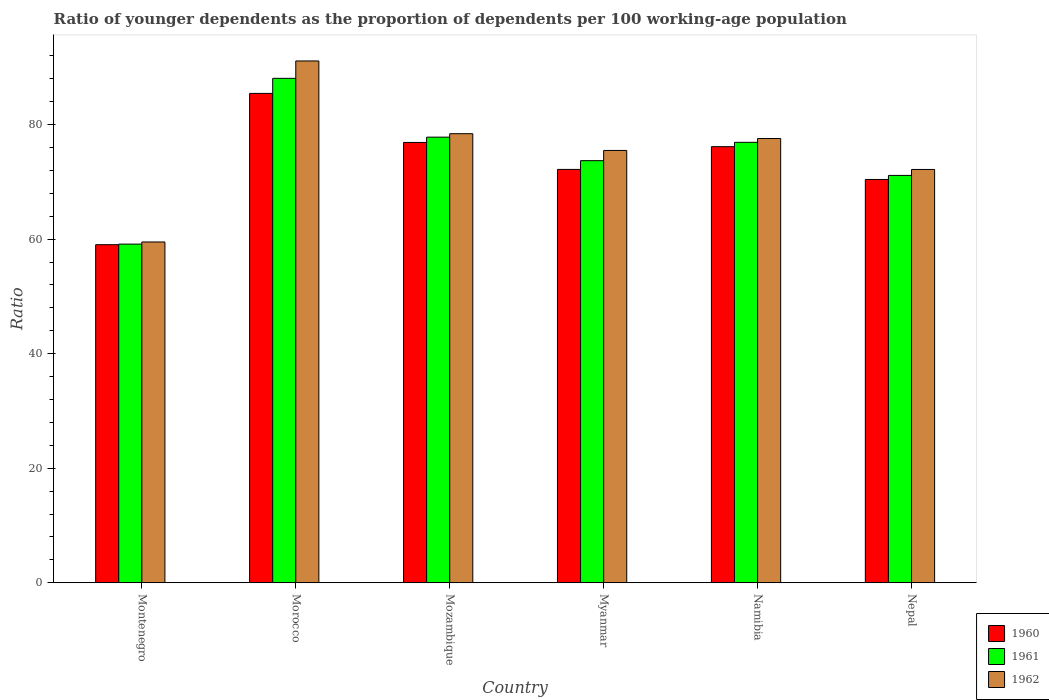How many different coloured bars are there?
Provide a short and direct response. 3. How many bars are there on the 1st tick from the right?
Provide a succinct answer. 3. What is the label of the 4th group of bars from the left?
Offer a terse response. Myanmar. What is the age dependency ratio(young) in 1962 in Morocco?
Make the answer very short. 91.12. Across all countries, what is the maximum age dependency ratio(young) in 1960?
Offer a very short reply. 85.46. Across all countries, what is the minimum age dependency ratio(young) in 1960?
Provide a succinct answer. 59.03. In which country was the age dependency ratio(young) in 1962 maximum?
Offer a very short reply. Morocco. In which country was the age dependency ratio(young) in 1961 minimum?
Your answer should be compact. Montenegro. What is the total age dependency ratio(young) in 1961 in the graph?
Your answer should be very brief. 446.8. What is the difference between the age dependency ratio(young) in 1962 in Mozambique and that in Namibia?
Your answer should be very brief. 0.84. What is the difference between the age dependency ratio(young) in 1961 in Montenegro and the age dependency ratio(young) in 1962 in Namibia?
Your answer should be compact. -18.44. What is the average age dependency ratio(young) in 1962 per country?
Offer a very short reply. 75.72. What is the difference between the age dependency ratio(young) of/in 1961 and age dependency ratio(young) of/in 1960 in Morocco?
Ensure brevity in your answer.  2.63. What is the ratio of the age dependency ratio(young) in 1961 in Montenegro to that in Mozambique?
Keep it short and to the point. 0.76. Is the age dependency ratio(young) in 1960 in Montenegro less than that in Myanmar?
Give a very brief answer. Yes. What is the difference between the highest and the second highest age dependency ratio(young) in 1960?
Give a very brief answer. -8.57. What is the difference between the highest and the lowest age dependency ratio(young) in 1962?
Provide a short and direct response. 31.61. Is the sum of the age dependency ratio(young) in 1962 in Montenegro and Namibia greater than the maximum age dependency ratio(young) in 1961 across all countries?
Make the answer very short. Yes. What does the 1st bar from the left in Mozambique represents?
Give a very brief answer. 1960. What does the 1st bar from the right in Mozambique represents?
Your answer should be compact. 1962. Are all the bars in the graph horizontal?
Your answer should be very brief. No. How many countries are there in the graph?
Give a very brief answer. 6. What is the difference between two consecutive major ticks on the Y-axis?
Offer a terse response. 20. Are the values on the major ticks of Y-axis written in scientific E-notation?
Keep it short and to the point. No. Does the graph contain grids?
Offer a very short reply. No. How many legend labels are there?
Offer a very short reply. 3. How are the legend labels stacked?
Provide a succinct answer. Vertical. What is the title of the graph?
Provide a succinct answer. Ratio of younger dependents as the proportion of dependents per 100 working-age population. Does "1996" appear as one of the legend labels in the graph?
Provide a succinct answer. No. What is the label or title of the Y-axis?
Offer a terse response. Ratio. What is the Ratio of 1960 in Montenegro?
Keep it short and to the point. 59.03. What is the Ratio in 1961 in Montenegro?
Offer a very short reply. 59.14. What is the Ratio of 1962 in Montenegro?
Your answer should be very brief. 59.51. What is the Ratio of 1960 in Morocco?
Your answer should be compact. 85.46. What is the Ratio in 1961 in Morocco?
Your response must be concise. 88.09. What is the Ratio in 1962 in Morocco?
Give a very brief answer. 91.12. What is the Ratio of 1960 in Mozambique?
Ensure brevity in your answer.  76.89. What is the Ratio in 1961 in Mozambique?
Your response must be concise. 77.82. What is the Ratio of 1962 in Mozambique?
Give a very brief answer. 78.42. What is the Ratio of 1960 in Myanmar?
Ensure brevity in your answer.  72.18. What is the Ratio of 1961 in Myanmar?
Offer a terse response. 73.71. What is the Ratio of 1962 in Myanmar?
Ensure brevity in your answer.  75.49. What is the Ratio of 1960 in Namibia?
Your response must be concise. 76.15. What is the Ratio of 1961 in Namibia?
Give a very brief answer. 76.91. What is the Ratio of 1962 in Namibia?
Offer a terse response. 77.58. What is the Ratio of 1960 in Nepal?
Offer a terse response. 70.43. What is the Ratio in 1961 in Nepal?
Your response must be concise. 71.13. What is the Ratio of 1962 in Nepal?
Ensure brevity in your answer.  72.17. Across all countries, what is the maximum Ratio in 1960?
Your answer should be very brief. 85.46. Across all countries, what is the maximum Ratio of 1961?
Give a very brief answer. 88.09. Across all countries, what is the maximum Ratio in 1962?
Provide a succinct answer. 91.12. Across all countries, what is the minimum Ratio of 1960?
Offer a terse response. 59.03. Across all countries, what is the minimum Ratio of 1961?
Give a very brief answer. 59.14. Across all countries, what is the minimum Ratio of 1962?
Provide a succinct answer. 59.51. What is the total Ratio in 1960 in the graph?
Your answer should be compact. 440.14. What is the total Ratio in 1961 in the graph?
Your response must be concise. 446.8. What is the total Ratio in 1962 in the graph?
Your response must be concise. 454.3. What is the difference between the Ratio of 1960 in Montenegro and that in Morocco?
Offer a terse response. -26.42. What is the difference between the Ratio in 1961 in Montenegro and that in Morocco?
Offer a terse response. -28.95. What is the difference between the Ratio of 1962 in Montenegro and that in Morocco?
Your answer should be very brief. -31.61. What is the difference between the Ratio of 1960 in Montenegro and that in Mozambique?
Offer a very short reply. -17.86. What is the difference between the Ratio of 1961 in Montenegro and that in Mozambique?
Offer a very short reply. -18.68. What is the difference between the Ratio of 1962 in Montenegro and that in Mozambique?
Keep it short and to the point. -18.91. What is the difference between the Ratio of 1960 in Montenegro and that in Myanmar?
Give a very brief answer. -13.15. What is the difference between the Ratio of 1961 in Montenegro and that in Myanmar?
Keep it short and to the point. -14.57. What is the difference between the Ratio of 1962 in Montenegro and that in Myanmar?
Your response must be concise. -15.98. What is the difference between the Ratio in 1960 in Montenegro and that in Namibia?
Make the answer very short. -17.12. What is the difference between the Ratio in 1961 in Montenegro and that in Namibia?
Your response must be concise. -17.78. What is the difference between the Ratio in 1962 in Montenegro and that in Namibia?
Your answer should be compact. -18.07. What is the difference between the Ratio in 1960 in Montenegro and that in Nepal?
Keep it short and to the point. -11.39. What is the difference between the Ratio in 1961 in Montenegro and that in Nepal?
Keep it short and to the point. -11.99. What is the difference between the Ratio in 1962 in Montenegro and that in Nepal?
Offer a terse response. -12.66. What is the difference between the Ratio of 1960 in Morocco and that in Mozambique?
Give a very brief answer. 8.57. What is the difference between the Ratio of 1961 in Morocco and that in Mozambique?
Your answer should be compact. 10.27. What is the difference between the Ratio of 1962 in Morocco and that in Mozambique?
Ensure brevity in your answer.  12.7. What is the difference between the Ratio of 1960 in Morocco and that in Myanmar?
Provide a succinct answer. 13.28. What is the difference between the Ratio in 1961 in Morocco and that in Myanmar?
Your answer should be compact. 14.38. What is the difference between the Ratio in 1962 in Morocco and that in Myanmar?
Your response must be concise. 15.63. What is the difference between the Ratio of 1960 in Morocco and that in Namibia?
Your response must be concise. 9.3. What is the difference between the Ratio in 1961 in Morocco and that in Namibia?
Your answer should be compact. 11.17. What is the difference between the Ratio in 1962 in Morocco and that in Namibia?
Give a very brief answer. 13.54. What is the difference between the Ratio of 1960 in Morocco and that in Nepal?
Provide a short and direct response. 15.03. What is the difference between the Ratio of 1961 in Morocco and that in Nepal?
Your answer should be very brief. 16.95. What is the difference between the Ratio of 1962 in Morocco and that in Nepal?
Your answer should be very brief. 18.95. What is the difference between the Ratio in 1960 in Mozambique and that in Myanmar?
Your answer should be compact. 4.71. What is the difference between the Ratio in 1961 in Mozambique and that in Myanmar?
Keep it short and to the point. 4.11. What is the difference between the Ratio in 1962 in Mozambique and that in Myanmar?
Your answer should be very brief. 2.92. What is the difference between the Ratio of 1960 in Mozambique and that in Namibia?
Your response must be concise. 0.74. What is the difference between the Ratio of 1961 in Mozambique and that in Namibia?
Your answer should be very brief. 0.9. What is the difference between the Ratio in 1962 in Mozambique and that in Namibia?
Your answer should be compact. 0.84. What is the difference between the Ratio in 1960 in Mozambique and that in Nepal?
Ensure brevity in your answer.  6.46. What is the difference between the Ratio of 1961 in Mozambique and that in Nepal?
Your answer should be compact. 6.68. What is the difference between the Ratio of 1962 in Mozambique and that in Nepal?
Make the answer very short. 6.24. What is the difference between the Ratio of 1960 in Myanmar and that in Namibia?
Make the answer very short. -3.97. What is the difference between the Ratio in 1961 in Myanmar and that in Namibia?
Offer a terse response. -3.2. What is the difference between the Ratio of 1962 in Myanmar and that in Namibia?
Offer a very short reply. -2.08. What is the difference between the Ratio in 1960 in Myanmar and that in Nepal?
Your answer should be very brief. 1.76. What is the difference between the Ratio in 1961 in Myanmar and that in Nepal?
Keep it short and to the point. 2.58. What is the difference between the Ratio in 1962 in Myanmar and that in Nepal?
Your answer should be compact. 3.32. What is the difference between the Ratio in 1960 in Namibia and that in Nepal?
Your answer should be compact. 5.73. What is the difference between the Ratio of 1961 in Namibia and that in Nepal?
Make the answer very short. 5.78. What is the difference between the Ratio in 1962 in Namibia and that in Nepal?
Offer a very short reply. 5.4. What is the difference between the Ratio in 1960 in Montenegro and the Ratio in 1961 in Morocco?
Make the answer very short. -29.05. What is the difference between the Ratio of 1960 in Montenegro and the Ratio of 1962 in Morocco?
Your response must be concise. -32.09. What is the difference between the Ratio in 1961 in Montenegro and the Ratio in 1962 in Morocco?
Provide a succinct answer. -31.98. What is the difference between the Ratio of 1960 in Montenegro and the Ratio of 1961 in Mozambique?
Provide a short and direct response. -18.78. What is the difference between the Ratio in 1960 in Montenegro and the Ratio in 1962 in Mozambique?
Your answer should be compact. -19.39. What is the difference between the Ratio in 1961 in Montenegro and the Ratio in 1962 in Mozambique?
Your answer should be very brief. -19.28. What is the difference between the Ratio in 1960 in Montenegro and the Ratio in 1961 in Myanmar?
Ensure brevity in your answer.  -14.68. What is the difference between the Ratio in 1960 in Montenegro and the Ratio in 1962 in Myanmar?
Your answer should be very brief. -16.46. What is the difference between the Ratio in 1961 in Montenegro and the Ratio in 1962 in Myanmar?
Offer a terse response. -16.36. What is the difference between the Ratio in 1960 in Montenegro and the Ratio in 1961 in Namibia?
Ensure brevity in your answer.  -17.88. What is the difference between the Ratio in 1960 in Montenegro and the Ratio in 1962 in Namibia?
Provide a succinct answer. -18.55. What is the difference between the Ratio of 1961 in Montenegro and the Ratio of 1962 in Namibia?
Your response must be concise. -18.44. What is the difference between the Ratio in 1960 in Montenegro and the Ratio in 1961 in Nepal?
Make the answer very short. -12.1. What is the difference between the Ratio of 1960 in Montenegro and the Ratio of 1962 in Nepal?
Offer a very short reply. -13.14. What is the difference between the Ratio in 1961 in Montenegro and the Ratio in 1962 in Nepal?
Give a very brief answer. -13.04. What is the difference between the Ratio in 1960 in Morocco and the Ratio in 1961 in Mozambique?
Your response must be concise. 7.64. What is the difference between the Ratio of 1960 in Morocco and the Ratio of 1962 in Mozambique?
Your response must be concise. 7.04. What is the difference between the Ratio of 1961 in Morocco and the Ratio of 1962 in Mozambique?
Provide a succinct answer. 9.67. What is the difference between the Ratio in 1960 in Morocco and the Ratio in 1961 in Myanmar?
Keep it short and to the point. 11.75. What is the difference between the Ratio in 1960 in Morocco and the Ratio in 1962 in Myanmar?
Provide a short and direct response. 9.96. What is the difference between the Ratio in 1961 in Morocco and the Ratio in 1962 in Myanmar?
Provide a succinct answer. 12.59. What is the difference between the Ratio in 1960 in Morocco and the Ratio in 1961 in Namibia?
Offer a very short reply. 8.54. What is the difference between the Ratio of 1960 in Morocco and the Ratio of 1962 in Namibia?
Your answer should be very brief. 7.88. What is the difference between the Ratio in 1961 in Morocco and the Ratio in 1962 in Namibia?
Offer a terse response. 10.51. What is the difference between the Ratio in 1960 in Morocco and the Ratio in 1961 in Nepal?
Ensure brevity in your answer.  14.33. What is the difference between the Ratio in 1960 in Morocco and the Ratio in 1962 in Nepal?
Give a very brief answer. 13.28. What is the difference between the Ratio of 1961 in Morocco and the Ratio of 1962 in Nepal?
Give a very brief answer. 15.91. What is the difference between the Ratio in 1960 in Mozambique and the Ratio in 1961 in Myanmar?
Ensure brevity in your answer.  3.18. What is the difference between the Ratio in 1960 in Mozambique and the Ratio in 1962 in Myanmar?
Your answer should be very brief. 1.4. What is the difference between the Ratio of 1961 in Mozambique and the Ratio of 1962 in Myanmar?
Give a very brief answer. 2.32. What is the difference between the Ratio in 1960 in Mozambique and the Ratio in 1961 in Namibia?
Offer a terse response. -0.02. What is the difference between the Ratio of 1960 in Mozambique and the Ratio of 1962 in Namibia?
Keep it short and to the point. -0.69. What is the difference between the Ratio of 1961 in Mozambique and the Ratio of 1962 in Namibia?
Give a very brief answer. 0.24. What is the difference between the Ratio in 1960 in Mozambique and the Ratio in 1961 in Nepal?
Provide a succinct answer. 5.76. What is the difference between the Ratio in 1960 in Mozambique and the Ratio in 1962 in Nepal?
Give a very brief answer. 4.72. What is the difference between the Ratio in 1961 in Mozambique and the Ratio in 1962 in Nepal?
Offer a very short reply. 5.64. What is the difference between the Ratio in 1960 in Myanmar and the Ratio in 1961 in Namibia?
Offer a very short reply. -4.73. What is the difference between the Ratio in 1960 in Myanmar and the Ratio in 1962 in Namibia?
Your response must be concise. -5.4. What is the difference between the Ratio of 1961 in Myanmar and the Ratio of 1962 in Namibia?
Provide a succinct answer. -3.87. What is the difference between the Ratio in 1960 in Myanmar and the Ratio in 1961 in Nepal?
Keep it short and to the point. 1.05. What is the difference between the Ratio of 1960 in Myanmar and the Ratio of 1962 in Nepal?
Offer a terse response. 0.01. What is the difference between the Ratio in 1961 in Myanmar and the Ratio in 1962 in Nepal?
Your answer should be very brief. 1.54. What is the difference between the Ratio in 1960 in Namibia and the Ratio in 1961 in Nepal?
Give a very brief answer. 5.02. What is the difference between the Ratio in 1960 in Namibia and the Ratio in 1962 in Nepal?
Your response must be concise. 3.98. What is the difference between the Ratio of 1961 in Namibia and the Ratio of 1962 in Nepal?
Offer a very short reply. 4.74. What is the average Ratio in 1960 per country?
Ensure brevity in your answer.  73.36. What is the average Ratio of 1961 per country?
Keep it short and to the point. 74.47. What is the average Ratio of 1962 per country?
Your answer should be compact. 75.72. What is the difference between the Ratio in 1960 and Ratio in 1961 in Montenegro?
Your answer should be very brief. -0.1. What is the difference between the Ratio in 1960 and Ratio in 1962 in Montenegro?
Give a very brief answer. -0.48. What is the difference between the Ratio in 1961 and Ratio in 1962 in Montenegro?
Your answer should be compact. -0.37. What is the difference between the Ratio in 1960 and Ratio in 1961 in Morocco?
Your answer should be very brief. -2.63. What is the difference between the Ratio of 1960 and Ratio of 1962 in Morocco?
Your answer should be very brief. -5.66. What is the difference between the Ratio in 1961 and Ratio in 1962 in Morocco?
Keep it short and to the point. -3.04. What is the difference between the Ratio in 1960 and Ratio in 1961 in Mozambique?
Provide a succinct answer. -0.93. What is the difference between the Ratio in 1960 and Ratio in 1962 in Mozambique?
Keep it short and to the point. -1.53. What is the difference between the Ratio in 1961 and Ratio in 1962 in Mozambique?
Keep it short and to the point. -0.6. What is the difference between the Ratio in 1960 and Ratio in 1961 in Myanmar?
Offer a very short reply. -1.53. What is the difference between the Ratio of 1960 and Ratio of 1962 in Myanmar?
Your answer should be very brief. -3.31. What is the difference between the Ratio of 1961 and Ratio of 1962 in Myanmar?
Give a very brief answer. -1.78. What is the difference between the Ratio of 1960 and Ratio of 1961 in Namibia?
Provide a succinct answer. -0.76. What is the difference between the Ratio of 1960 and Ratio of 1962 in Namibia?
Offer a terse response. -1.42. What is the difference between the Ratio in 1961 and Ratio in 1962 in Namibia?
Keep it short and to the point. -0.66. What is the difference between the Ratio in 1960 and Ratio in 1961 in Nepal?
Make the answer very short. -0.71. What is the difference between the Ratio of 1960 and Ratio of 1962 in Nepal?
Offer a very short reply. -1.75. What is the difference between the Ratio of 1961 and Ratio of 1962 in Nepal?
Ensure brevity in your answer.  -1.04. What is the ratio of the Ratio of 1960 in Montenegro to that in Morocco?
Give a very brief answer. 0.69. What is the ratio of the Ratio in 1961 in Montenegro to that in Morocco?
Provide a succinct answer. 0.67. What is the ratio of the Ratio in 1962 in Montenegro to that in Morocco?
Make the answer very short. 0.65. What is the ratio of the Ratio of 1960 in Montenegro to that in Mozambique?
Your answer should be very brief. 0.77. What is the ratio of the Ratio of 1961 in Montenegro to that in Mozambique?
Provide a succinct answer. 0.76. What is the ratio of the Ratio of 1962 in Montenegro to that in Mozambique?
Give a very brief answer. 0.76. What is the ratio of the Ratio of 1960 in Montenegro to that in Myanmar?
Your answer should be very brief. 0.82. What is the ratio of the Ratio of 1961 in Montenegro to that in Myanmar?
Offer a very short reply. 0.8. What is the ratio of the Ratio in 1962 in Montenegro to that in Myanmar?
Your response must be concise. 0.79. What is the ratio of the Ratio of 1960 in Montenegro to that in Namibia?
Make the answer very short. 0.78. What is the ratio of the Ratio of 1961 in Montenegro to that in Namibia?
Your answer should be compact. 0.77. What is the ratio of the Ratio of 1962 in Montenegro to that in Namibia?
Provide a short and direct response. 0.77. What is the ratio of the Ratio of 1960 in Montenegro to that in Nepal?
Provide a short and direct response. 0.84. What is the ratio of the Ratio of 1961 in Montenegro to that in Nepal?
Make the answer very short. 0.83. What is the ratio of the Ratio in 1962 in Montenegro to that in Nepal?
Give a very brief answer. 0.82. What is the ratio of the Ratio in 1960 in Morocco to that in Mozambique?
Offer a terse response. 1.11. What is the ratio of the Ratio of 1961 in Morocco to that in Mozambique?
Provide a succinct answer. 1.13. What is the ratio of the Ratio in 1962 in Morocco to that in Mozambique?
Offer a very short reply. 1.16. What is the ratio of the Ratio of 1960 in Morocco to that in Myanmar?
Ensure brevity in your answer.  1.18. What is the ratio of the Ratio of 1961 in Morocco to that in Myanmar?
Your response must be concise. 1.2. What is the ratio of the Ratio of 1962 in Morocco to that in Myanmar?
Give a very brief answer. 1.21. What is the ratio of the Ratio in 1960 in Morocco to that in Namibia?
Provide a succinct answer. 1.12. What is the ratio of the Ratio in 1961 in Morocco to that in Namibia?
Your answer should be compact. 1.15. What is the ratio of the Ratio in 1962 in Morocco to that in Namibia?
Your answer should be compact. 1.17. What is the ratio of the Ratio of 1960 in Morocco to that in Nepal?
Provide a succinct answer. 1.21. What is the ratio of the Ratio in 1961 in Morocco to that in Nepal?
Your answer should be compact. 1.24. What is the ratio of the Ratio in 1962 in Morocco to that in Nepal?
Your answer should be compact. 1.26. What is the ratio of the Ratio of 1960 in Mozambique to that in Myanmar?
Provide a short and direct response. 1.07. What is the ratio of the Ratio in 1961 in Mozambique to that in Myanmar?
Your answer should be compact. 1.06. What is the ratio of the Ratio of 1962 in Mozambique to that in Myanmar?
Your answer should be very brief. 1.04. What is the ratio of the Ratio of 1960 in Mozambique to that in Namibia?
Make the answer very short. 1.01. What is the ratio of the Ratio in 1961 in Mozambique to that in Namibia?
Your answer should be very brief. 1.01. What is the ratio of the Ratio of 1962 in Mozambique to that in Namibia?
Give a very brief answer. 1.01. What is the ratio of the Ratio in 1960 in Mozambique to that in Nepal?
Provide a succinct answer. 1.09. What is the ratio of the Ratio in 1961 in Mozambique to that in Nepal?
Give a very brief answer. 1.09. What is the ratio of the Ratio of 1962 in Mozambique to that in Nepal?
Keep it short and to the point. 1.09. What is the ratio of the Ratio of 1960 in Myanmar to that in Namibia?
Your response must be concise. 0.95. What is the ratio of the Ratio in 1961 in Myanmar to that in Namibia?
Make the answer very short. 0.96. What is the ratio of the Ratio in 1962 in Myanmar to that in Namibia?
Keep it short and to the point. 0.97. What is the ratio of the Ratio of 1960 in Myanmar to that in Nepal?
Offer a terse response. 1.02. What is the ratio of the Ratio in 1961 in Myanmar to that in Nepal?
Provide a short and direct response. 1.04. What is the ratio of the Ratio of 1962 in Myanmar to that in Nepal?
Your answer should be very brief. 1.05. What is the ratio of the Ratio in 1960 in Namibia to that in Nepal?
Your answer should be very brief. 1.08. What is the ratio of the Ratio of 1961 in Namibia to that in Nepal?
Your answer should be compact. 1.08. What is the ratio of the Ratio of 1962 in Namibia to that in Nepal?
Offer a very short reply. 1.07. What is the difference between the highest and the second highest Ratio in 1960?
Provide a succinct answer. 8.57. What is the difference between the highest and the second highest Ratio in 1961?
Your answer should be very brief. 10.27. What is the difference between the highest and the second highest Ratio in 1962?
Keep it short and to the point. 12.7. What is the difference between the highest and the lowest Ratio of 1960?
Give a very brief answer. 26.42. What is the difference between the highest and the lowest Ratio in 1961?
Keep it short and to the point. 28.95. What is the difference between the highest and the lowest Ratio of 1962?
Ensure brevity in your answer.  31.61. 